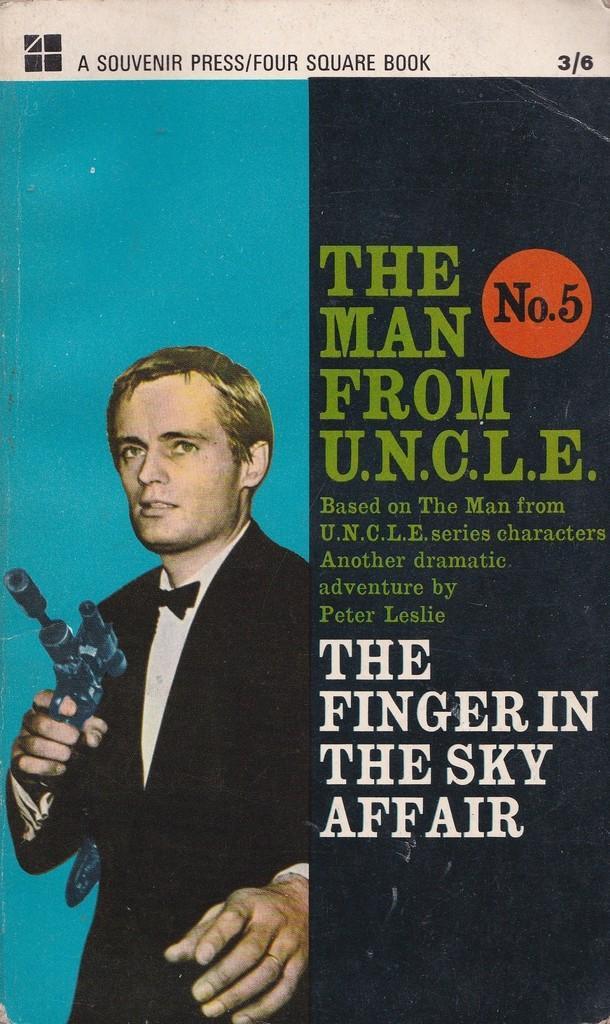Can you describe this image briefly? This image is of a paper. In which there is a depiction of a person and there is some text. 